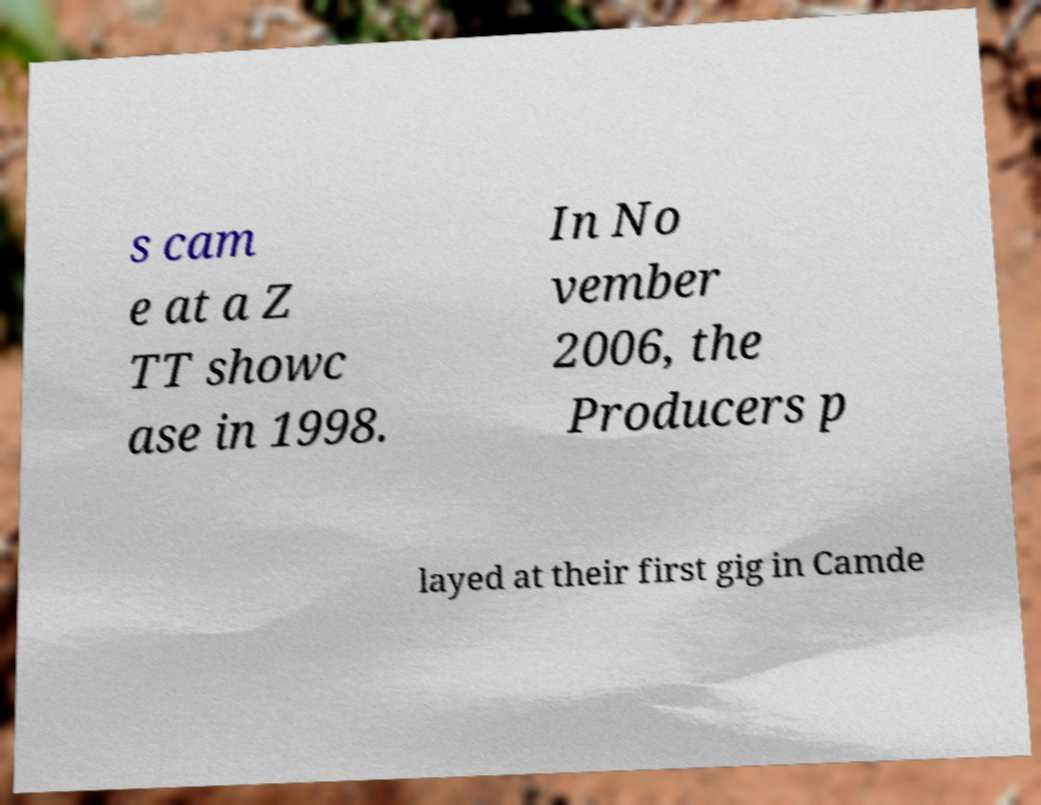For documentation purposes, I need the text within this image transcribed. Could you provide that? s cam e at a Z TT showc ase in 1998. In No vember 2006, the Producers p layed at their first gig in Camde 